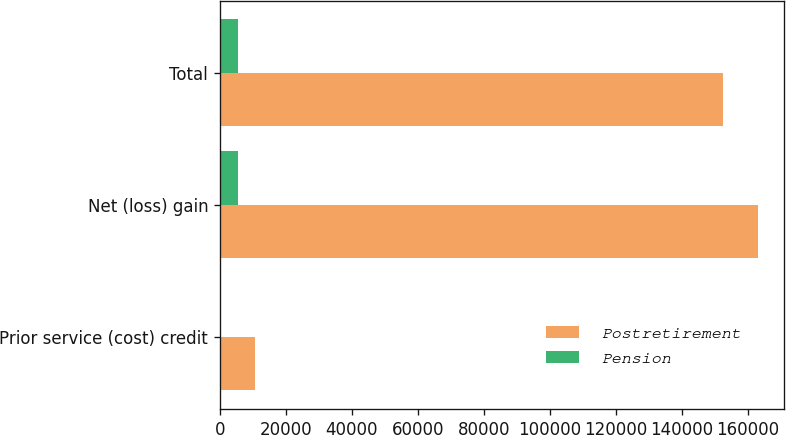Convert chart to OTSL. <chart><loc_0><loc_0><loc_500><loc_500><stacked_bar_chart><ecel><fcel>Prior service (cost) credit<fcel>Net (loss) gain<fcel>Total<nl><fcel>Postretirement<fcel>10619<fcel>163012<fcel>152393<nl><fcel>Pension<fcel>27<fcel>5511<fcel>5538<nl></chart> 